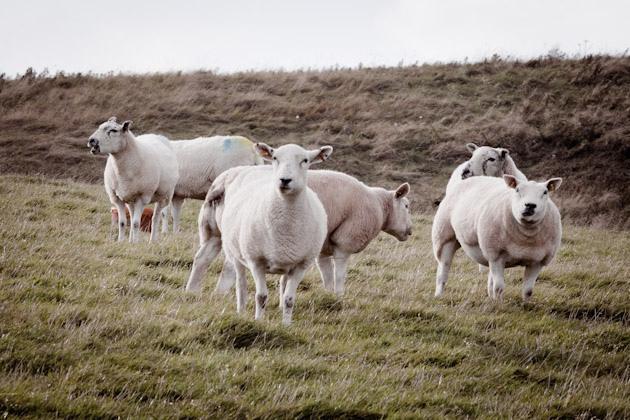How many sheep are there?
Give a very brief answer. 6. 